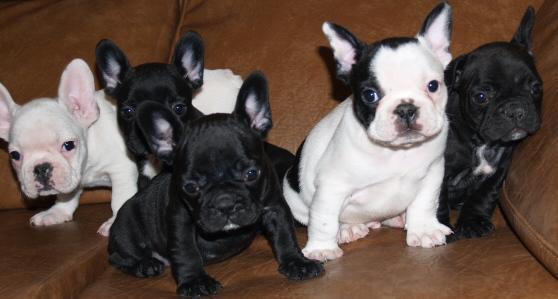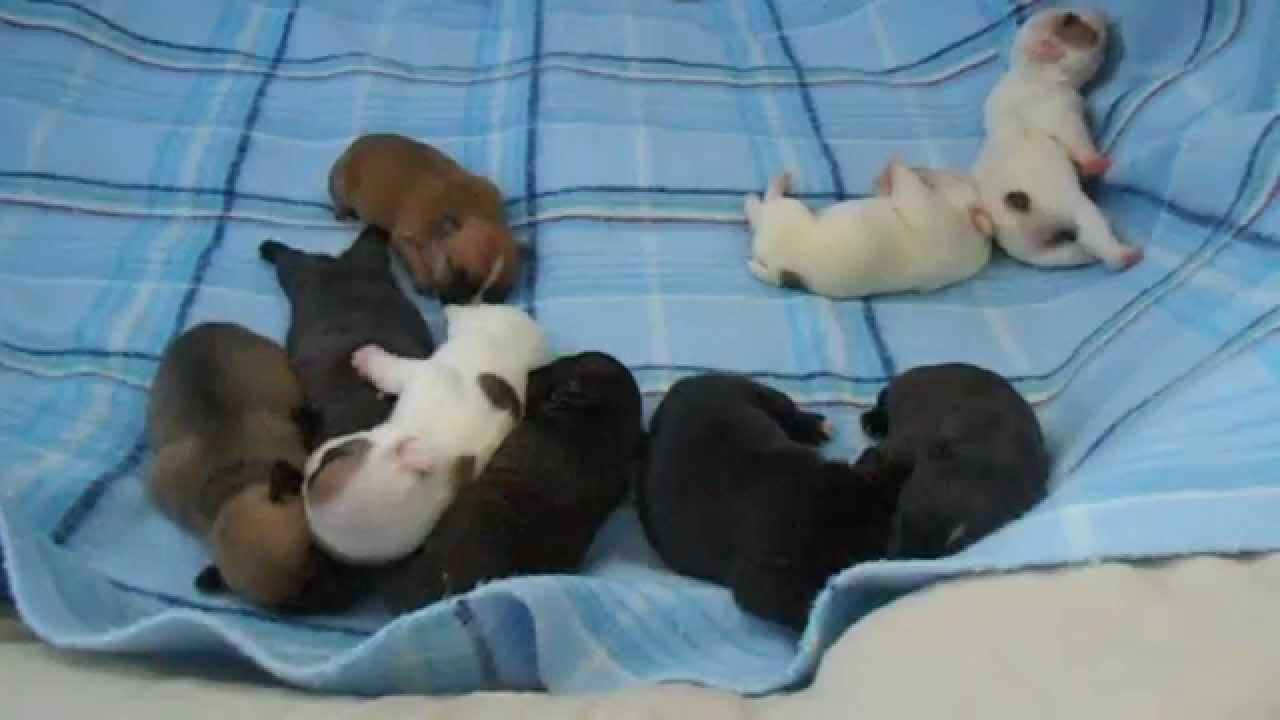The first image is the image on the left, the second image is the image on the right. Evaluate the accuracy of this statement regarding the images: "the image pair has no more than 4 puppies". Is it true? Answer yes or no. No. The first image is the image on the left, the second image is the image on the right. Assess this claim about the two images: "There is an image with no more and no less than two dogs.". Correct or not? Answer yes or no. No. 